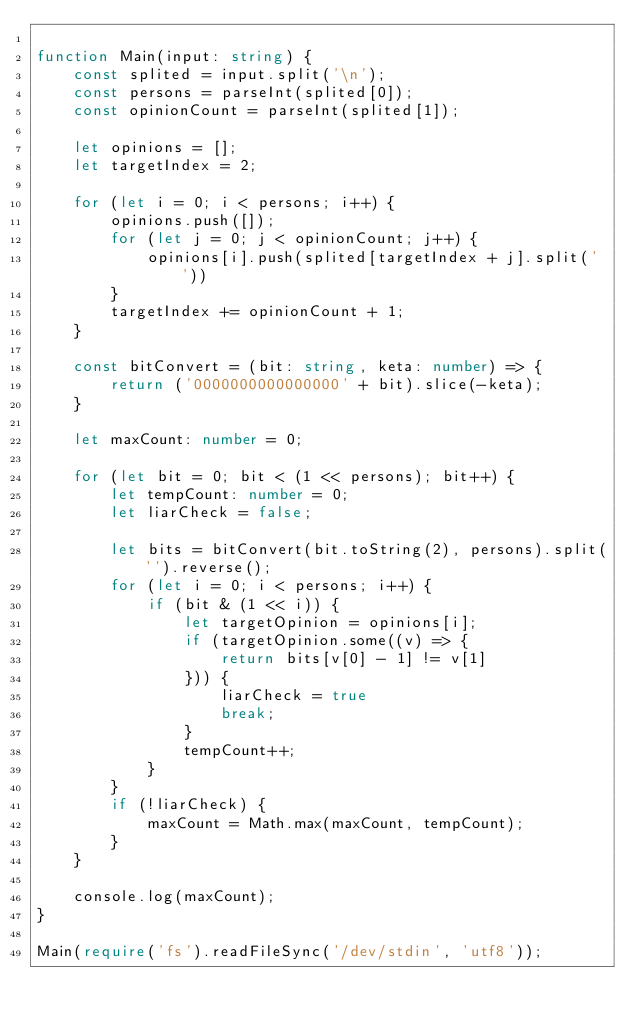Convert code to text. <code><loc_0><loc_0><loc_500><loc_500><_TypeScript_>
function Main(input: string) {
    const splited = input.split('\n');
    const persons = parseInt(splited[0]);
    const opinionCount = parseInt(splited[1]);

    let opinions = [];
    let targetIndex = 2;

    for (let i = 0; i < persons; i++) {
        opinions.push([]);
        for (let j = 0; j < opinionCount; j++) {
            opinions[i].push(splited[targetIndex + j].split(' '))
        }
        targetIndex += opinionCount + 1;
    }

    const bitConvert = (bit: string, keta: number) => {
        return ('0000000000000000' + bit).slice(-keta);
    }

    let maxCount: number = 0;

    for (let bit = 0; bit < (1 << persons); bit++) {
        let tempCount: number = 0;
        let liarCheck = false;

        let bits = bitConvert(bit.toString(2), persons).split('').reverse();
        for (let i = 0; i < persons; i++) {
            if (bit & (1 << i)) {
                let targetOpinion = opinions[i];
                if (targetOpinion.some((v) => {
                    return bits[v[0] - 1] != v[1]
                })) {
                    liarCheck = true
                    break;
                }
                tempCount++;
            }
        }
        if (!liarCheck) {
            maxCount = Math.max(maxCount, tempCount);
        }
    }

    console.log(maxCount);
}

Main(require('fs').readFileSync('/dev/stdin', 'utf8'));</code> 